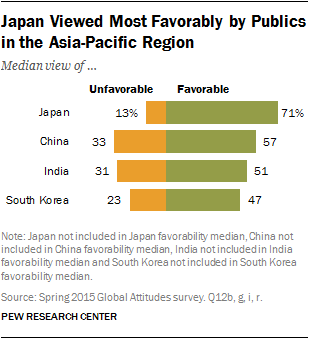Draw attention to some important aspects in this diagram. Yellow color is used to represent the value of unfavorable. Japan has the largest disparity between positive and negative opinions. 